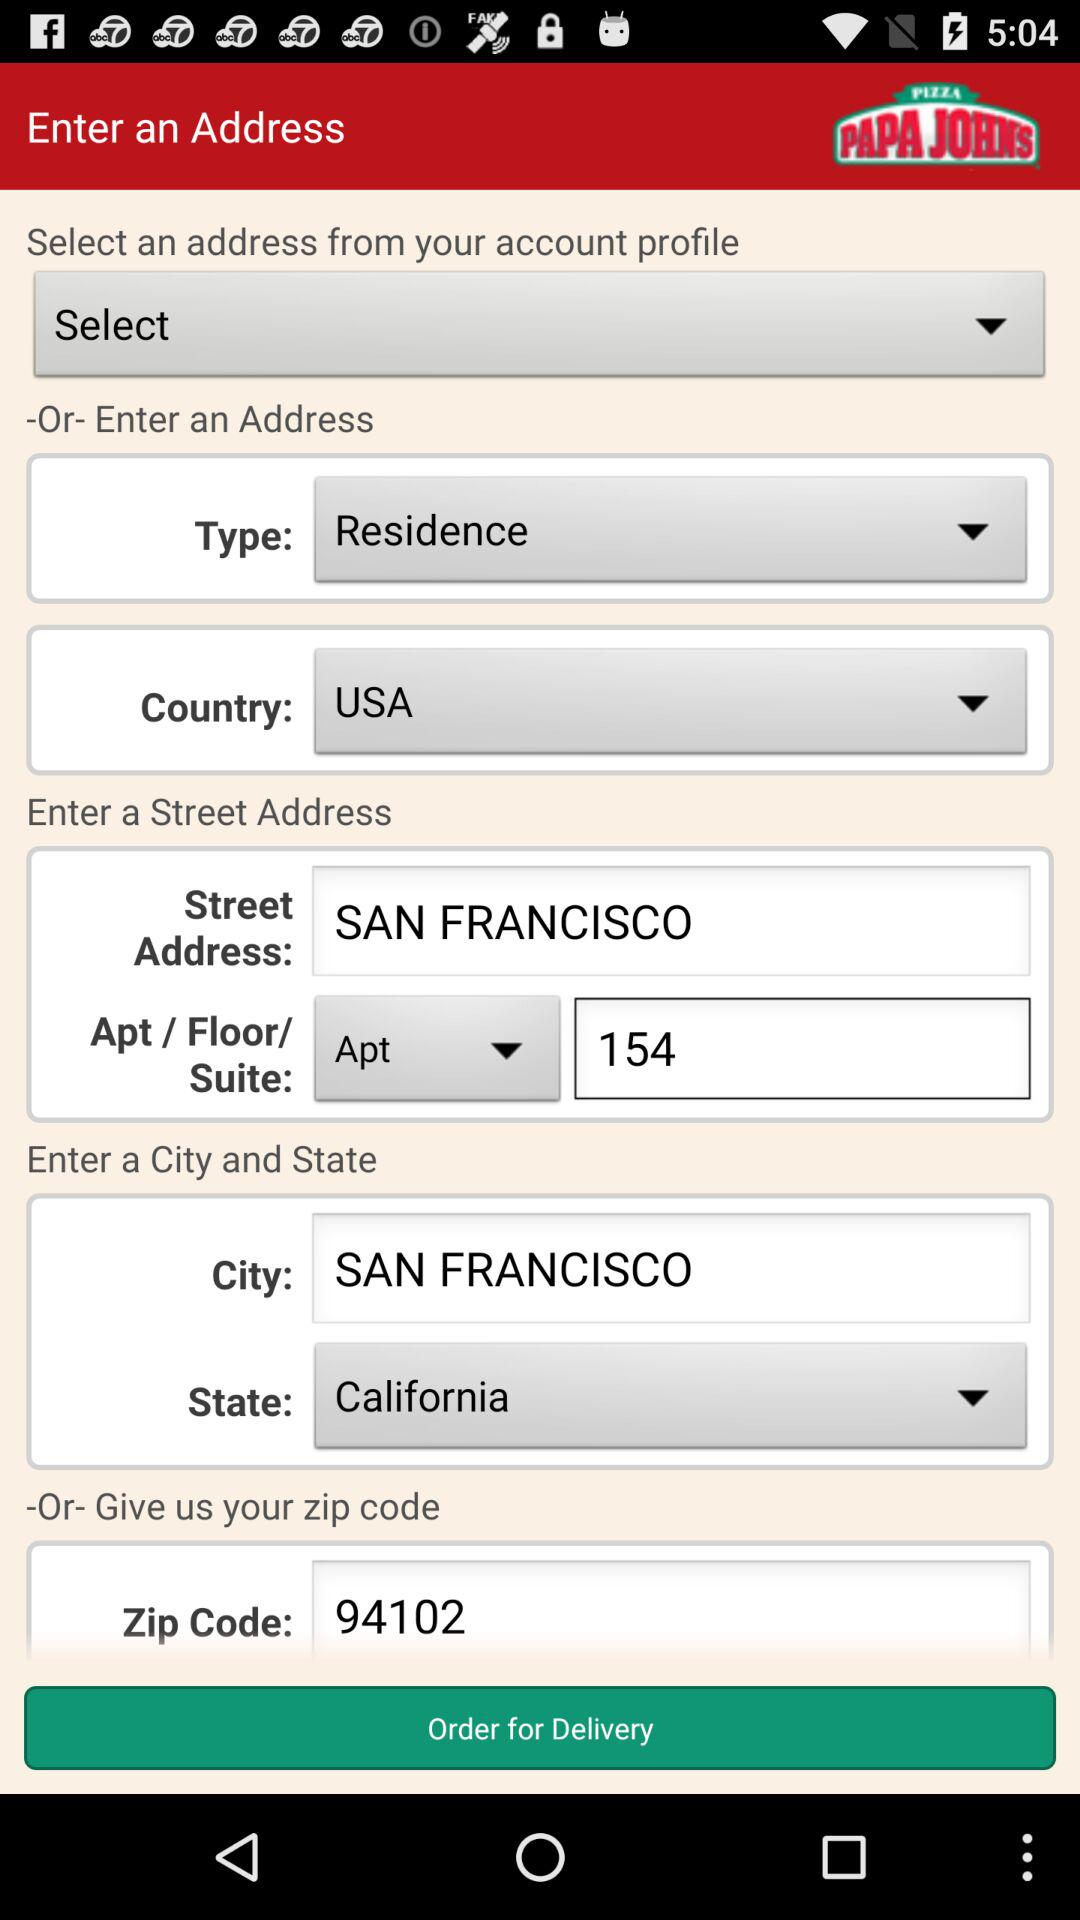Which is the selected state? The selected state is California. 